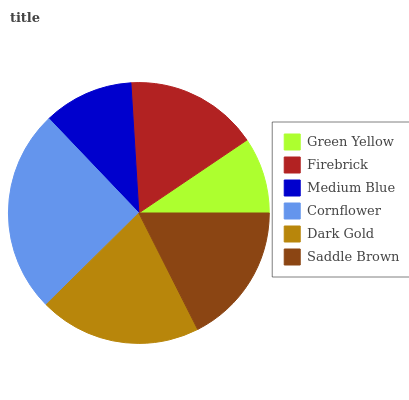Is Green Yellow the minimum?
Answer yes or no. Yes. Is Cornflower the maximum?
Answer yes or no. Yes. Is Firebrick the minimum?
Answer yes or no. No. Is Firebrick the maximum?
Answer yes or no. No. Is Firebrick greater than Green Yellow?
Answer yes or no. Yes. Is Green Yellow less than Firebrick?
Answer yes or no. Yes. Is Green Yellow greater than Firebrick?
Answer yes or no. No. Is Firebrick less than Green Yellow?
Answer yes or no. No. Is Saddle Brown the high median?
Answer yes or no. Yes. Is Firebrick the low median?
Answer yes or no. Yes. Is Medium Blue the high median?
Answer yes or no. No. Is Dark Gold the low median?
Answer yes or no. No. 